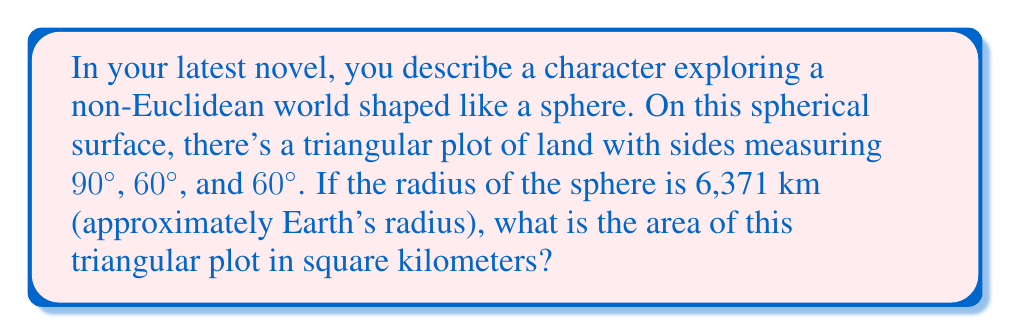Help me with this question. Let's approach this step-by-step:

1) In spherical geometry, the area of a triangle is given by the formula:

   $$A = R^2(α + β + γ - π)$$

   where $R$ is the radius of the sphere, and $α$, $β$, and $γ$ are the angles of the triangle in radians.

2) We're given the angles in degrees: 90°, 60°, and 60°. Let's convert them to radians:
   
   90° = $\frac{\pi}{2}$ radians
   60° = $\frac{\pi}{3}$ radians

3) Substituting into our formula:

   $$A = R^2(\frac{\pi}{2} + \frac{\pi}{3} + \frac{\pi}{3} - \pi)$$

4) Simplify:

   $$A = R^2(\frac{\pi}{2} + \frac{2\pi}{3} - \pi) = R^2(\frac{3\pi}{6} + \frac{4\pi}{6} - \frac{6\pi}{6}) = R^2(\frac{\pi}{6})$$

5) Now, let's substitute $R = 6,371$ km:

   $$A = (6,371)^2 \cdot \frac{\pi}{6}$$

6) Calculate:

   $$A ≈ 6,739,580 \text{ km}^2$$
Answer: 6,739,580 km² 